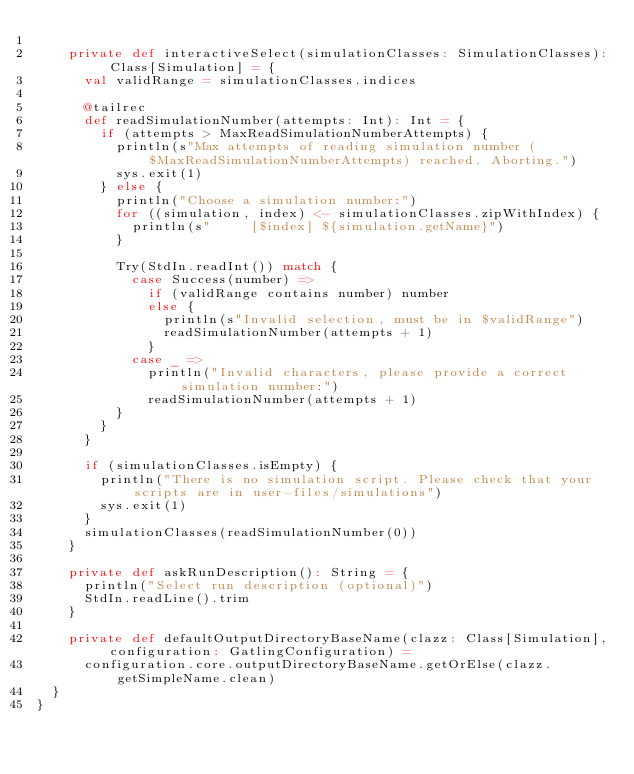Convert code to text. <code><loc_0><loc_0><loc_500><loc_500><_Scala_>
    private def interactiveSelect(simulationClasses: SimulationClasses): Class[Simulation] = {
      val validRange = simulationClasses.indices

      @tailrec
      def readSimulationNumber(attempts: Int): Int = {
        if (attempts > MaxReadSimulationNumberAttempts) {
          println(s"Max attempts of reading simulation number ($MaxReadSimulationNumberAttempts) reached. Aborting.")
          sys.exit(1)
        } else {
          println("Choose a simulation number:")
          for ((simulation, index) <- simulationClasses.zipWithIndex) {
            println(s"     [$index] ${simulation.getName}")
          }

          Try(StdIn.readInt()) match {
            case Success(number) =>
              if (validRange contains number) number
              else {
                println(s"Invalid selection, must be in $validRange")
                readSimulationNumber(attempts + 1)
              }
            case _ =>
              println("Invalid characters, please provide a correct simulation number:")
              readSimulationNumber(attempts + 1)
          }
        }
      }

      if (simulationClasses.isEmpty) {
        println("There is no simulation script. Please check that your scripts are in user-files/simulations")
        sys.exit(1)
      }
      simulationClasses(readSimulationNumber(0))
    }

    private def askRunDescription(): String = {
      println("Select run description (optional)")
      StdIn.readLine().trim
    }

    private def defaultOutputDirectoryBaseName(clazz: Class[Simulation], configuration: GatlingConfiguration) =
      configuration.core.outputDirectoryBaseName.getOrElse(clazz.getSimpleName.clean)
  }
}
</code> 